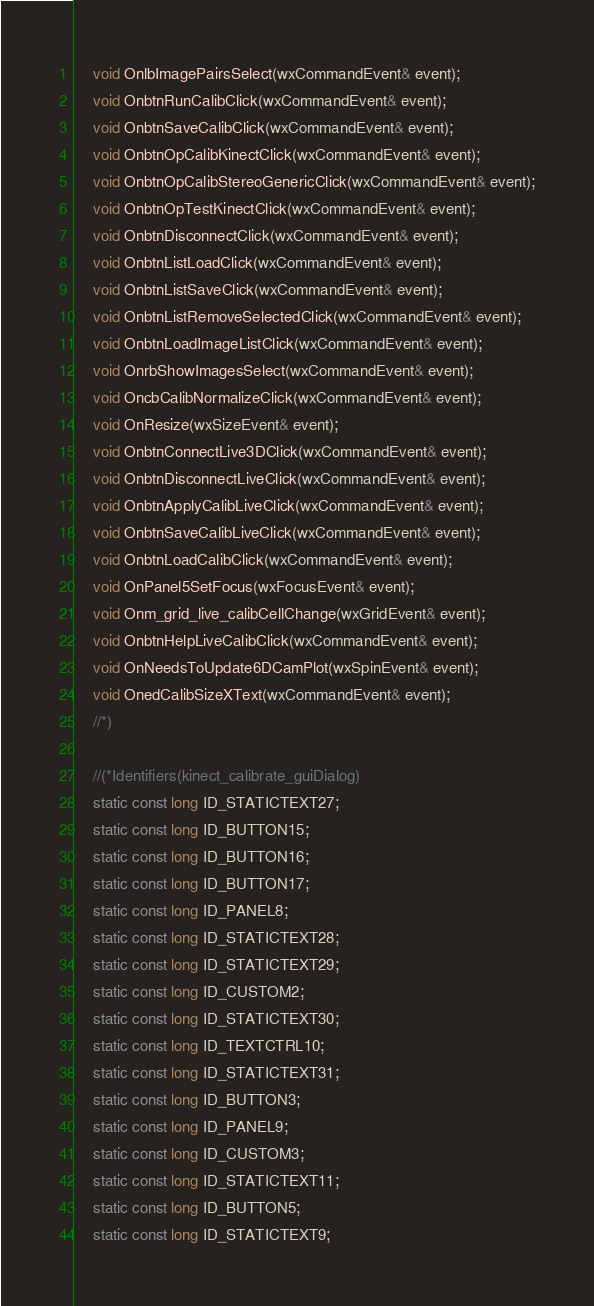Convert code to text. <code><loc_0><loc_0><loc_500><loc_500><_C_>	void OnlbImagePairsSelect(wxCommandEvent& event);
	void OnbtnRunCalibClick(wxCommandEvent& event);
	void OnbtnSaveCalibClick(wxCommandEvent& event);
	void OnbtnOpCalibKinectClick(wxCommandEvent& event);
	void OnbtnOpCalibStereoGenericClick(wxCommandEvent& event);
	void OnbtnOpTestKinectClick(wxCommandEvent& event);
	void OnbtnDisconnectClick(wxCommandEvent& event);
	void OnbtnListLoadClick(wxCommandEvent& event);
	void OnbtnListSaveClick(wxCommandEvent& event);
	void OnbtnListRemoveSelectedClick(wxCommandEvent& event);
	void OnbtnLoadImageListClick(wxCommandEvent& event);
	void OnrbShowImagesSelect(wxCommandEvent& event);
	void OncbCalibNormalizeClick(wxCommandEvent& event);
	void OnResize(wxSizeEvent& event);
	void OnbtnConnectLive3DClick(wxCommandEvent& event);
	void OnbtnDisconnectLiveClick(wxCommandEvent& event);
	void OnbtnApplyCalibLiveClick(wxCommandEvent& event);
	void OnbtnSaveCalibLiveClick(wxCommandEvent& event);
	void OnbtnLoadCalibClick(wxCommandEvent& event);
	void OnPanel5SetFocus(wxFocusEvent& event);
	void Onm_grid_live_calibCellChange(wxGridEvent& event);
	void OnbtnHelpLiveCalibClick(wxCommandEvent& event);
	void OnNeedsToUpdate6DCamPlot(wxSpinEvent& event);
	void OnedCalibSizeXText(wxCommandEvent& event);
	//*)

	//(*Identifiers(kinect_calibrate_guiDialog)
	static const long ID_STATICTEXT27;
	static const long ID_BUTTON15;
	static const long ID_BUTTON16;
	static const long ID_BUTTON17;
	static const long ID_PANEL8;
	static const long ID_STATICTEXT28;
	static const long ID_STATICTEXT29;
	static const long ID_CUSTOM2;
	static const long ID_STATICTEXT30;
	static const long ID_TEXTCTRL10;
	static const long ID_STATICTEXT31;
	static const long ID_BUTTON3;
	static const long ID_PANEL9;
	static const long ID_CUSTOM3;
	static const long ID_STATICTEXT11;
	static const long ID_BUTTON5;
	static const long ID_STATICTEXT9;</code> 